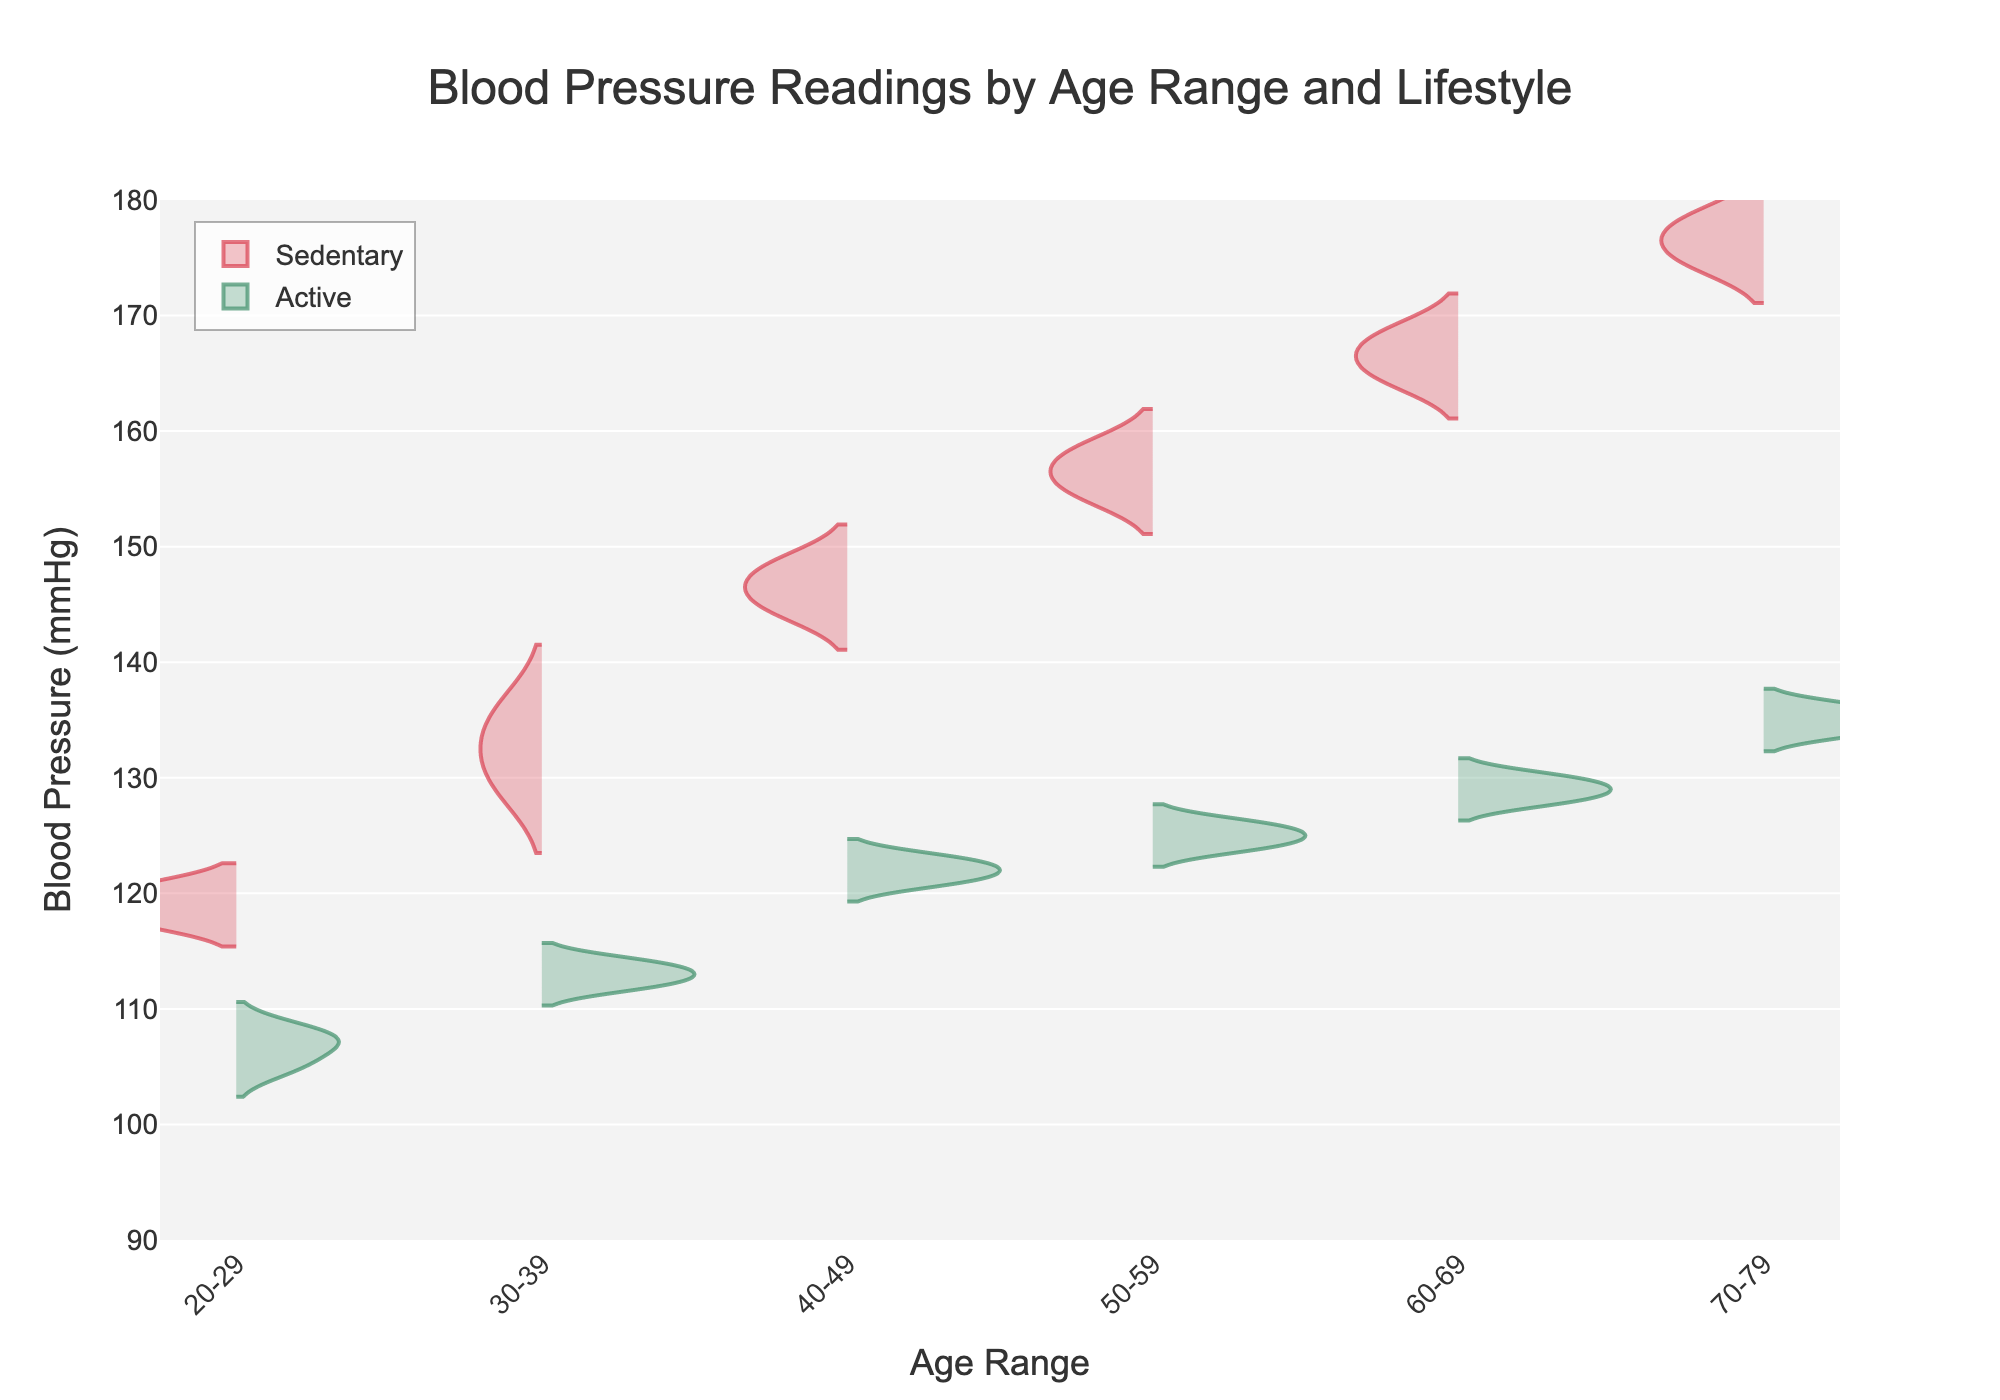What is the title of the figure? The title of the figure is prominently displayed at the top center.
Answer: Blood Pressure Readings by Age Range and Lifestyle What does the x-axis represent? The x-axis represents the different age ranges categorized in the dataset. These ranges are labeled from left to right along the horizontal axis.
Answer: Age Range What is the y-axis range for blood pressure measurements? The y-axis range is specified, with values running from a minimum of 90 mmHg to a maximum of 180 mmHg. This range is indicated along the vertical axis.
Answer: 90-180 mmHg Which age range shows the highest average blood pressure for sedentary individuals? By visually comparing the peaks of the sedentary violins across age ranges, the age range 70-79 demonstrates the highest average blood pressure.
Answer: 70-79 How do the median blood pressures for sedentary and active lifestyles compare in the 50-59 age range? The median is typically located at the thickest part of the violin plot. In the 50-59 age range, the median for sedentary individuals is higher compared to active individuals.
Answer: Sedentary > Active Is there a distinct difference between sedentary and active lifestyles in the 20-29 age range based on the violin plots? By observing the spread and central tendency of both violins, it can be noted that sedentary individuals generally have higher blood pressure than active individuals in the 20-29 age range.
Answer: Yes What is the general trend in blood pressure as age increases for active individuals? Observing the sequential increase in the center of the violin plots for active individuals across age ranges, the trend indicates that blood pressure generally increases with age.
Answer: Increases Between which age ranges is the spread of blood pressure values widest for sedentary individuals? By comparing the breadth of the violin plots for sedentary individuals, the age range 60-69 appears to have the widest spread of blood pressure values.
Answer: 60-69 Which lifestyle group generally has lower blood pressure readings across all age ranges? By comparing the positions of the violin plots for both sedentary and active lifestyles across all age ranges, the active group consistently shows lower blood pressure readings.
Answer: Active 